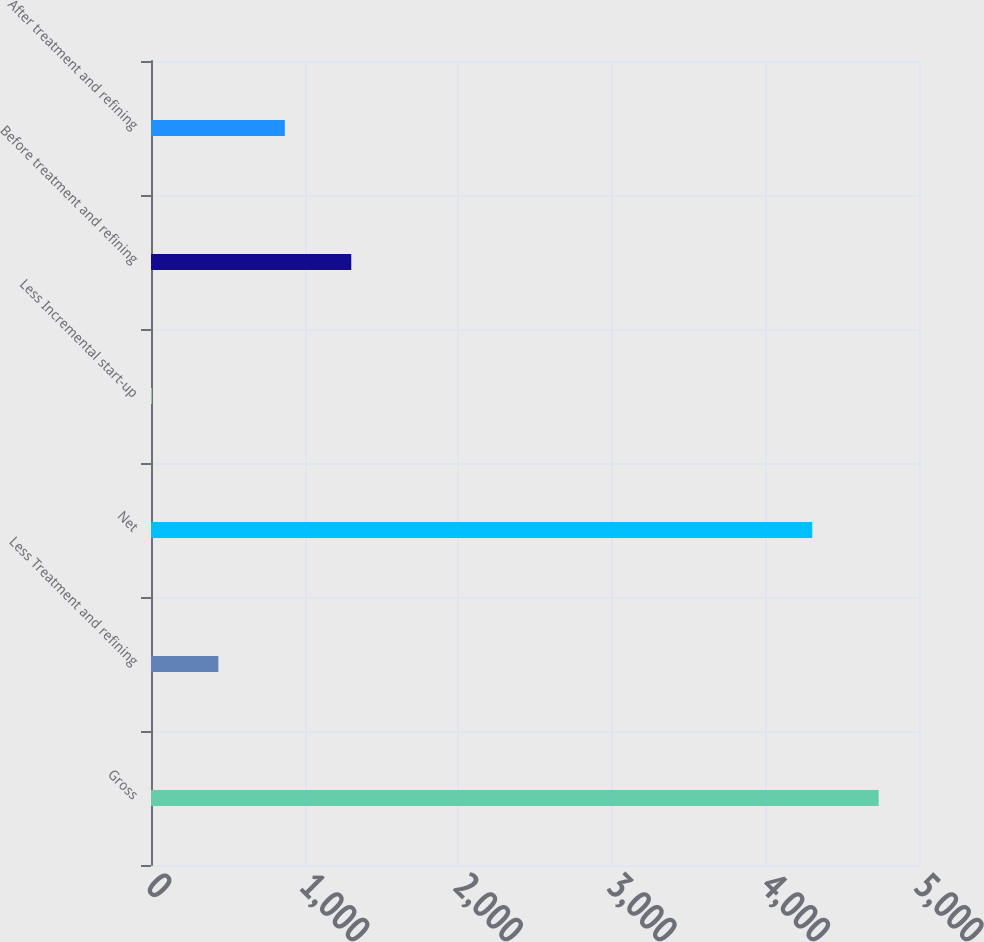Convert chart. <chart><loc_0><loc_0><loc_500><loc_500><bar_chart><fcel>Gross<fcel>Less Treatment and refining<fcel>Net<fcel>Less Incremental start-up<fcel>Before treatment and refining<fcel>After treatment and refining<nl><fcel>4737.6<fcel>438.6<fcel>4305<fcel>6<fcel>1303.8<fcel>871.2<nl></chart> 